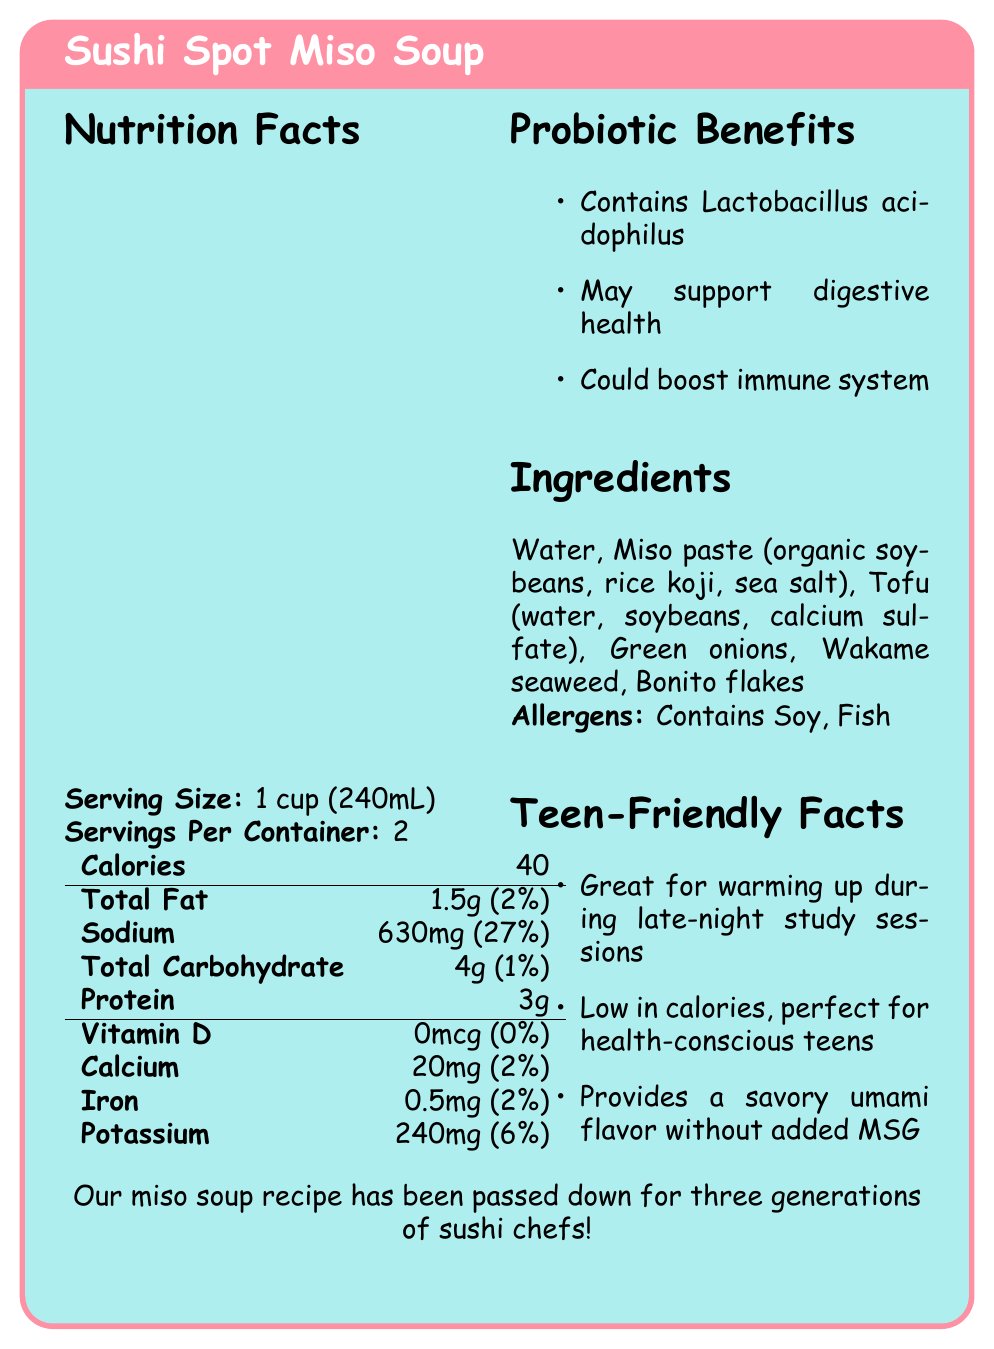what is the serving size of the Sushi Spot Miso Soup? The serving size is listed under "Serving Size" in the Nutrition Facts section.
Answer: 1 cup (240mL) How many servings are there per container? The number of servings per container is mentioned right below the serving size in the Nutrition Facts section.
Answer: 2 How much sodium does one serving contain? Sodium content per serving is listed under the "Sodium" in the Nutrition Facts table.
Answer: 630mg What is the percentage of daily value for calcium? The daily value percentage for calcium is indicated as 2% in the Nutrition Facts table.
Answer: 2% What is one of the probiotic benefits mentioned? Under the "Probiotic Benefits" section, it is listed that one of the benefits includes containing Lactobacillus acidophilus.
Answer: Contains Lactobacillus acidophilus How many calories are in one serving of the miso soup? The calorie content for one serving is shown at the top of the Nutrition Facts table.
Answer: 40 calories Which of the following is NOT an ingredient in the Sushi Spot Miso Soup? A. Bonito flakes B. Green onions C. Chicken broth D. Wakame seaweed Only ingredients A, B, D are listed in the Ingredients section.
Answer: C. Chicken broth What percentage of the daily value for sodium does one serving of the miso soup provide? A. 10% B. 15% C. 27% D. 32% The daily value percentage for sodium is listed as 27% in the Nutrition Facts table.
Answer: C. 27% Does the miso soup contain any allergens? The document states "Contains Soy, Fish" under the "Allergens" section.
Answer: Yes Is the miso soup low in calories? The document mentions in the "Teen-Friendly Facts" section that it is low in calories.
Answer: Yes Summarize the main idea of the document. The entire document is focused on delivering detailed nutritional information and benefits of the Sushi Spot Miso Soup, aimed at health-conscious individuals, particularly teens, emphasizing its traditional recipe and health perks.
Answer: The document provides nutrition facts, probiotic benefits, ingredients list, allergen information, and teen-friendly facts about Sushi Spot Miso Soup. It highlights that the soup is low in calories, contains beneficial probiotics, and includes a savory flavor without added MSG. Additionally, it notes the long-standing family recipe tradition. How can you prepare the miso soup? The document does not mention detailed preparation steps other than "Stir well before consuming. Best served hot."
Answer: Not enough information 